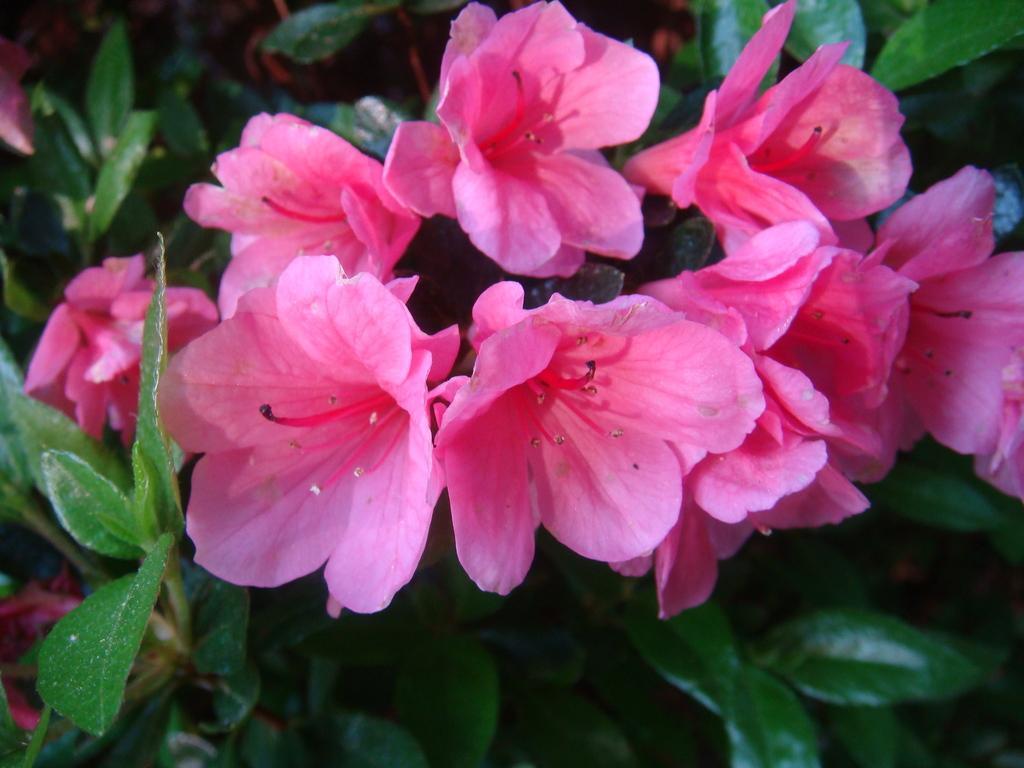Can you describe this image briefly? In the image in the center we can see plants and few pink color flowers. 